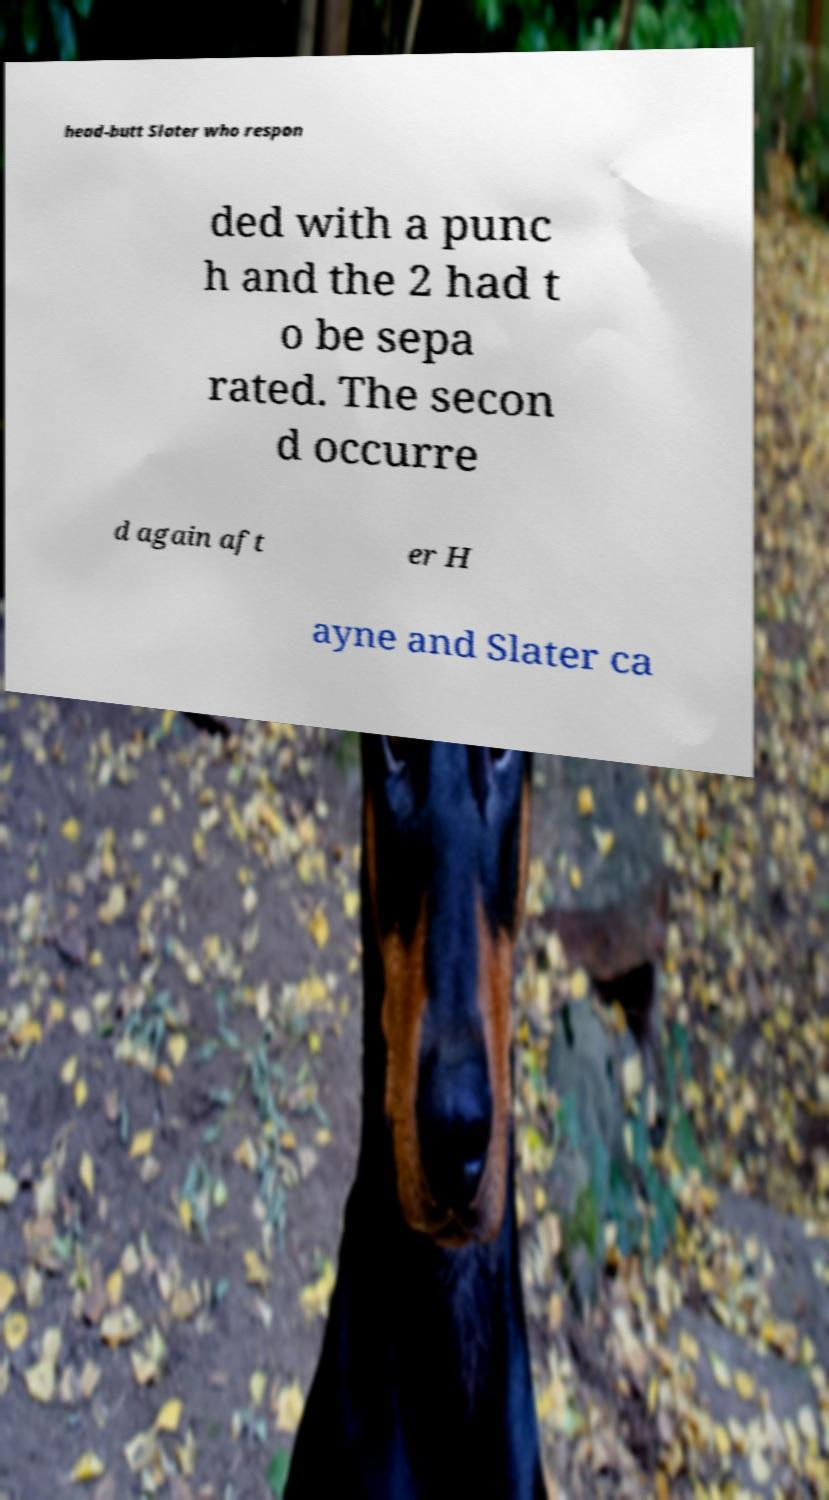There's text embedded in this image that I need extracted. Can you transcribe it verbatim? head-butt Slater who respon ded with a punc h and the 2 had t o be sepa rated. The secon d occurre d again aft er H ayne and Slater ca 